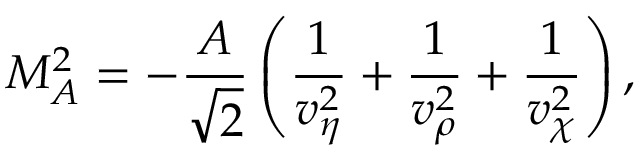<formula> <loc_0><loc_0><loc_500><loc_500>M _ { A } ^ { 2 } = - \frac { A } { \sqrt { 2 } } \left ( \frac { 1 } { v _ { \eta } ^ { 2 } } + \frac { 1 } { v _ { \rho } ^ { 2 } } + \frac { 1 } { v _ { \chi } ^ { 2 } } \right ) ,</formula> 